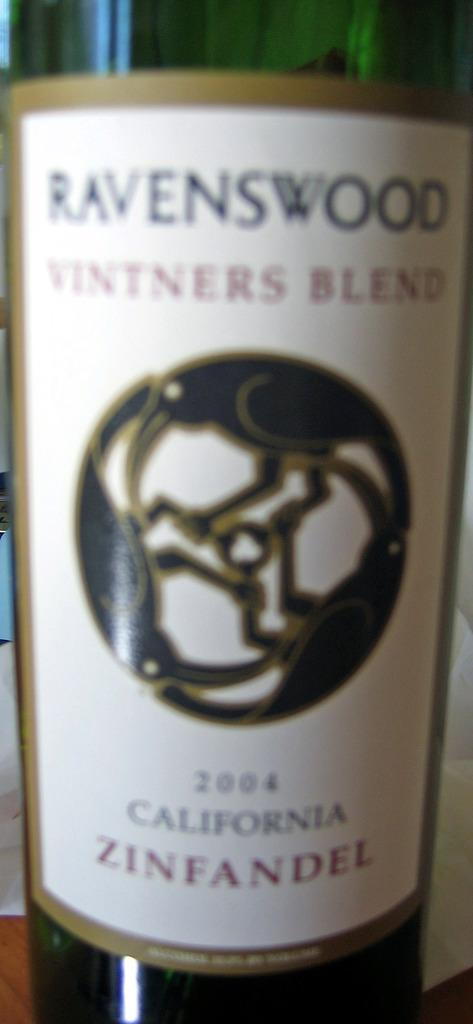<image>
Write a terse but informative summary of the picture. Bottle of alcohol with a label that says 2004 on it. 